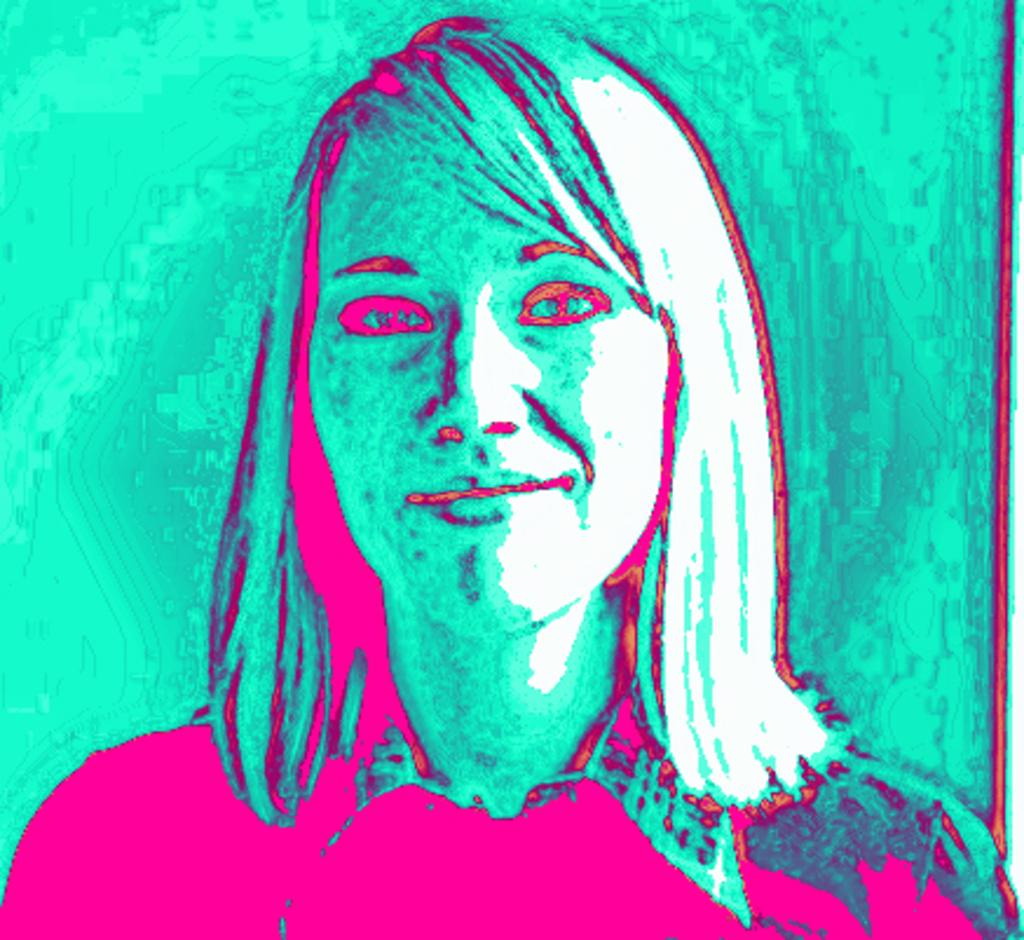What is the main subject of the image? The main subject of the image is a woman. What can you tell me about the nature of the image? The image is an edited image. What type of tray is the woman holding in the image? There is no tray present in the image, as it features an edited image of a woman. How many feathers can be seen on the woman's head in the image? There are no feathers present on the woman's head in the image. What type of apples can be seen in the image? There are no apples present in the image. 